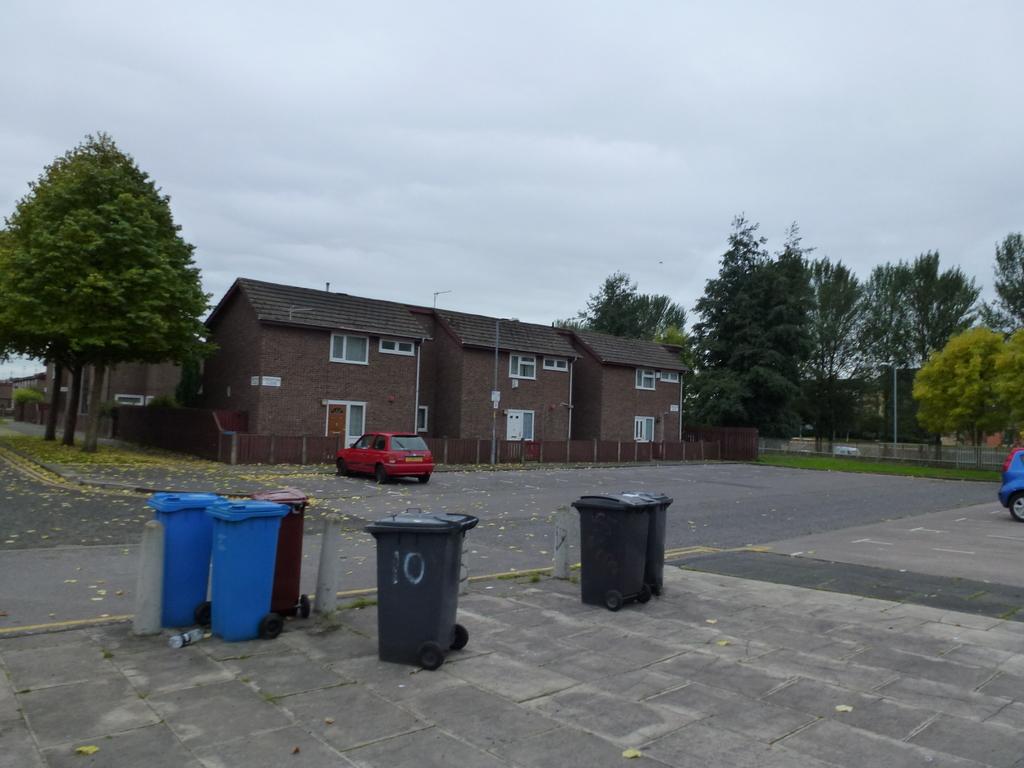What number is written on the trash can in the middle?
Offer a very short reply. 10. 